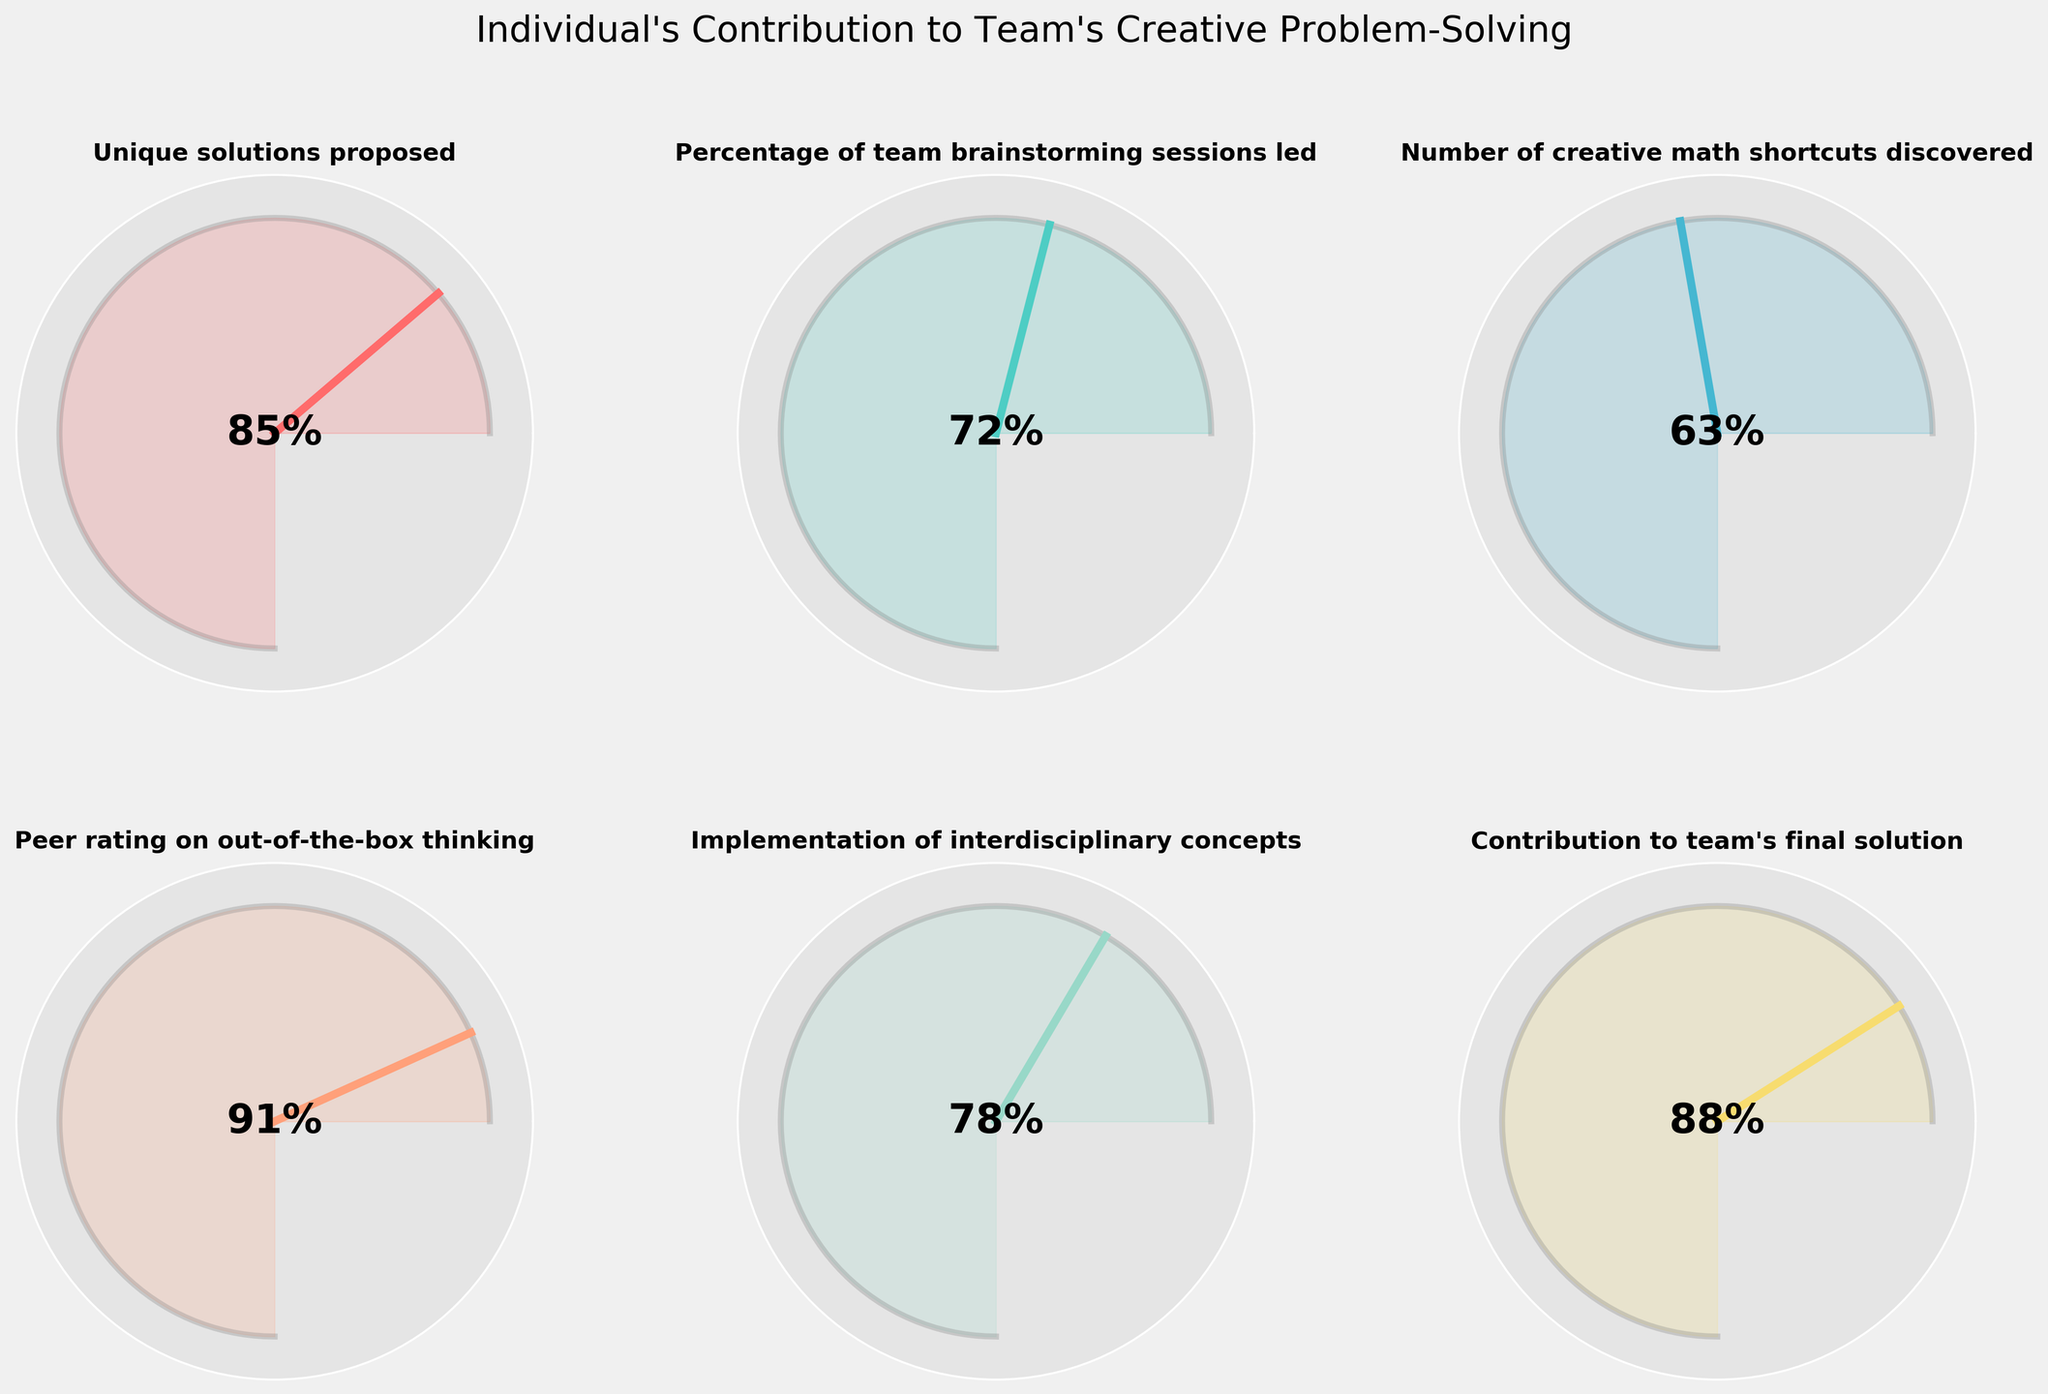What is the maximum value for "Unique solutions proposed"? The value for "Unique solutions proposed" is depicted as 85, and the gauge shows that the maximum value for this metric is 100. This is discernible since all the gauges have a scale from 0 to 100.
Answer: 100 How many metrics have values greater than 80%? We can count the number of metrics where the needle points to more than 80%. For each gauge: 
- "Unique solutions proposed" is 85% (greater than 80)
- "Peer rating on out-of-the-box thinking" is 91% (greater than 80)
- "Contribution to team's final solution" is 88% (greater than 80)
Thus, there are 3 metrics with values greater than 80%.
Answer: 3 Which metric has the lowest value and what is that value? By looking at the lowest point the gauge needles point to, "Number of creative math shortcuts discovered" has the lowest value at 63%.
Answer: "Number of creative math shortcuts discovered" at 63% Calculate the average percentage value of all the metrics shown. Add all the metric values and divide by the number of metrics: (85 + 72 + 63 + 91 + 78 + 88) / 6 = 477 / 6 = 79.5
Answer: 79.5% Which metric appears to be the team's most highly rated in "Individual's Contribution to Team's Creative Problem-Solving"? Based on the gauge positions, "Peer rating on out-of-the-box thinking" has the highest value of 91%, making it the highest-rated metric.
Answer: "Peer rating on out-of-the-box thinking" at 91% What value indicates the implementation of interdisciplinary concepts? Checking the gauge for "Implementation of interdisciplinary concepts," we see the needle points to 78%.
Answer: 78% Is the percentage of team brainstorming sessions led higher or lower than the contribution to the team's final solution? The gauge for "Percentage of team brainstorming sessions led" is at 72%, while "Contribution to team's final solution" is at 88%. Since 72% is less than 88%, the team brainstorming sessions led is lower.
Answer: Lower How does "Unique solutions proposed" compare to "Number of creative math shortcuts discovered"? By comparing the two gauge positions, "Unique solutions proposed" is at 85% and "Number of creative math shortcuts discovered" is at 63%. Thus, "Unique solutions proposed" is higher.
Answer: "Unique solutions proposed" is higher What is the step-by-step process to find the range of the values of all metrics? First, identify the highest and lowest values among the metrics:
- Highest: "Peer rating on out-of-the-box thinking" at 91%
- Lowest: "Number of creative math shortcuts discovered" at 63%
Next, compute the range by subtracting the lowest value from the highest value: 91% - 63% = 28%.
Answer: 28% 